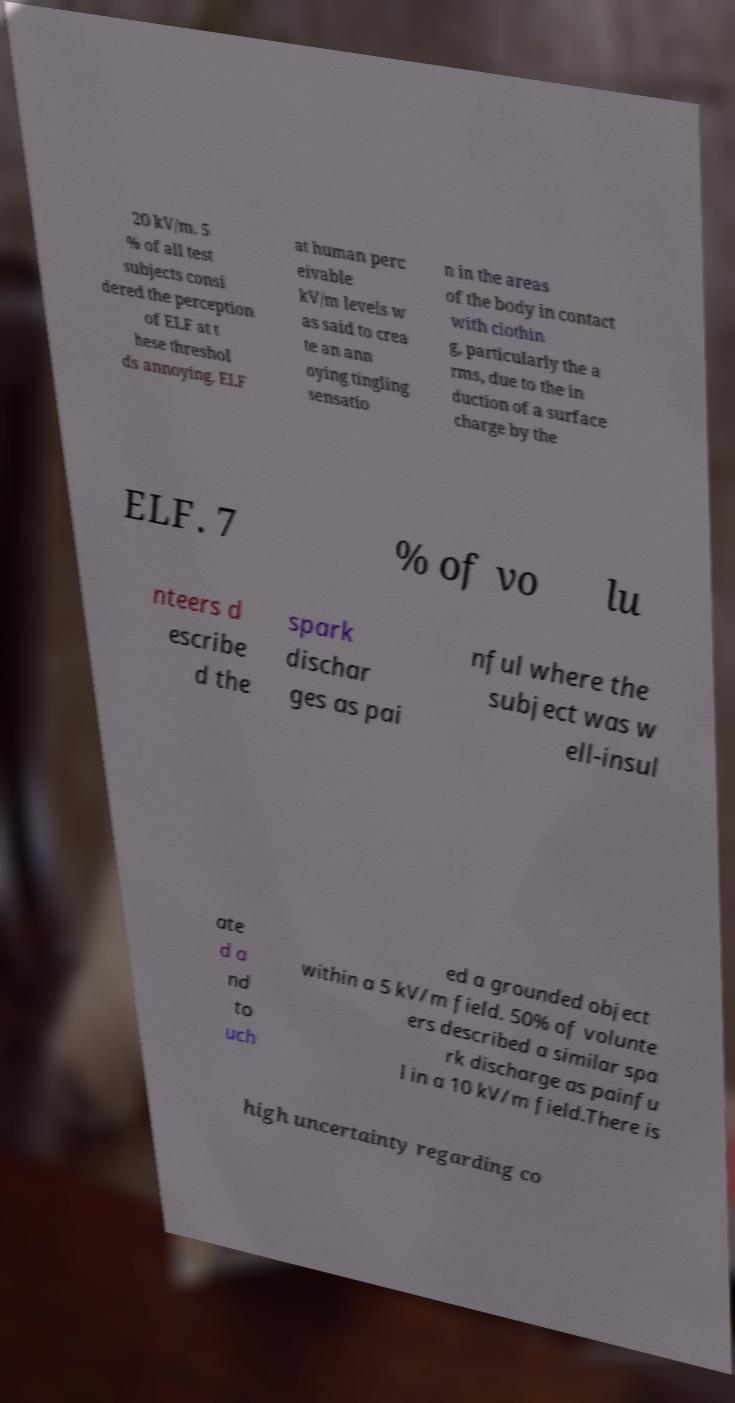Can you read and provide the text displayed in the image?This photo seems to have some interesting text. Can you extract and type it out for me? 20 kV/m. 5 % of all test subjects consi dered the perception of ELF at t hese threshol ds annoying. ELF at human perc eivable kV/m levels w as said to crea te an ann oying tingling sensatio n in the areas of the body in contact with clothin g, particularly the a rms, due to the in duction of a surface charge by the ELF. 7 % of vo lu nteers d escribe d the spark dischar ges as pai nful where the subject was w ell-insul ate d a nd to uch ed a grounded object within a 5 kV/m field. 50% of volunte ers described a similar spa rk discharge as painfu l in a 10 kV/m field.There is high uncertainty regarding co 